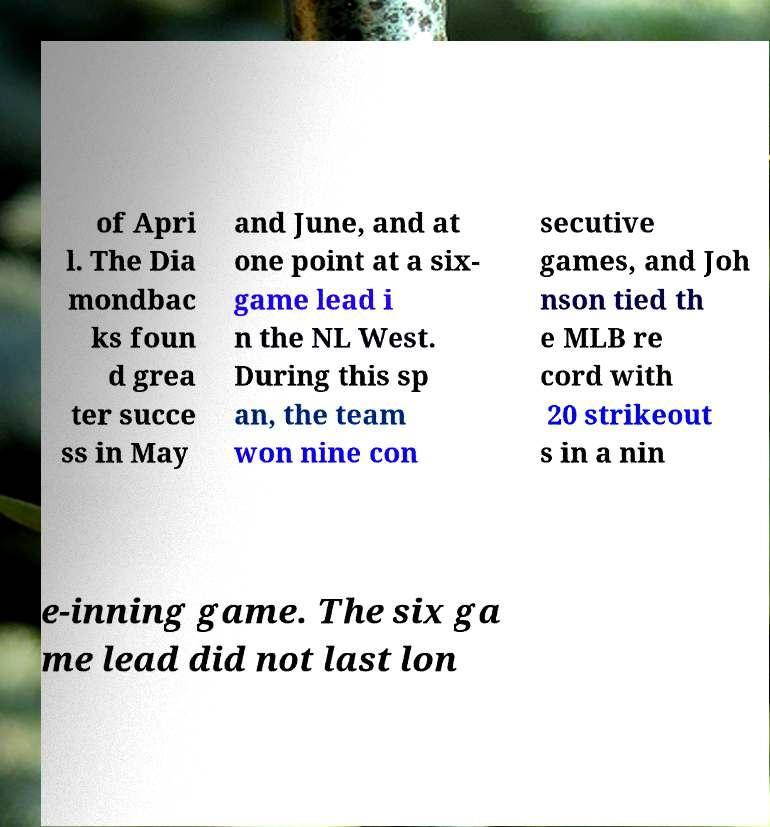Could you extract and type out the text from this image? of Apri l. The Dia mondbac ks foun d grea ter succe ss in May and June, and at one point at a six- game lead i n the NL West. During this sp an, the team won nine con secutive games, and Joh nson tied th e MLB re cord with 20 strikeout s in a nin e-inning game. The six ga me lead did not last lon 